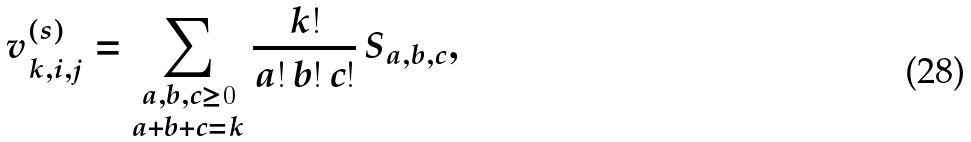Convert formula to latex. <formula><loc_0><loc_0><loc_500><loc_500>v ^ { ( s ) } _ { k , i , j } = \sum _ { \substack { a , b , c \geq 0 \\ a + b + c = k } } \frac { k ! } { a ! \, b ! \, c ! } \, S _ { a , b , c } ,</formula> 